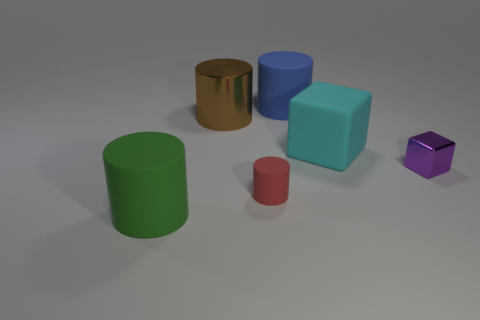Is the number of big cyan matte objects greater than the number of big cylinders?
Your answer should be compact. No. What material is the green cylinder?
Your answer should be very brief. Rubber. There is a metal thing to the right of the brown shiny thing; is its size the same as the brown cylinder?
Offer a very short reply. No. There is a block to the right of the cyan thing; what is its size?
Make the answer very short. Small. Is there anything else that has the same material as the tiny red cylinder?
Give a very brief answer. Yes. What number of gray metal cylinders are there?
Your answer should be very brief. 0. Is the large metallic object the same color as the tiny metallic object?
Provide a succinct answer. No. What is the color of the matte cylinder that is to the right of the big brown thing and in front of the tiny purple shiny thing?
Make the answer very short. Red. There is a tiny matte object; are there any tiny red matte cylinders left of it?
Your answer should be compact. No. How many purple things are right of the rubber cylinder that is on the left side of the tiny red matte object?
Make the answer very short. 1. 